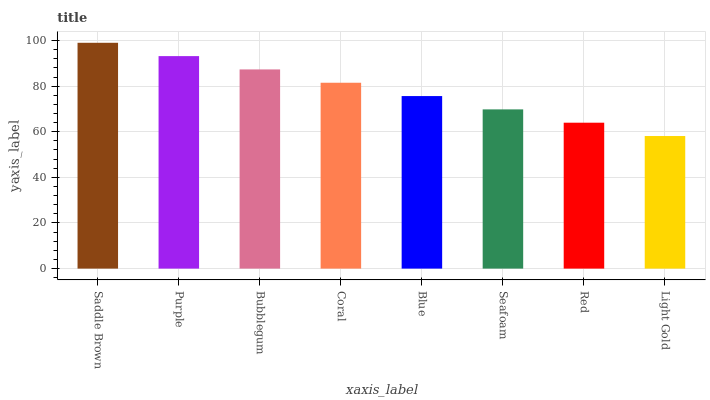Is Light Gold the minimum?
Answer yes or no. Yes. Is Saddle Brown the maximum?
Answer yes or no. Yes. Is Purple the minimum?
Answer yes or no. No. Is Purple the maximum?
Answer yes or no. No. Is Saddle Brown greater than Purple?
Answer yes or no. Yes. Is Purple less than Saddle Brown?
Answer yes or no. Yes. Is Purple greater than Saddle Brown?
Answer yes or no. No. Is Saddle Brown less than Purple?
Answer yes or no. No. Is Coral the high median?
Answer yes or no. Yes. Is Blue the low median?
Answer yes or no. Yes. Is Purple the high median?
Answer yes or no. No. Is Seafoam the low median?
Answer yes or no. No. 